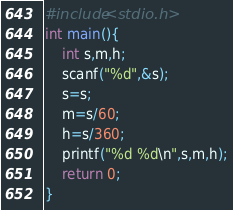<code> <loc_0><loc_0><loc_500><loc_500><_C_>#include<stdio.h>
int main(){
	int s,m,h;
	scanf("%d",&s);
	s=s;
	m=s/60;
	h=s/360;
	printf("%d %d\n",s,m,h);
	return 0;
}</code> 